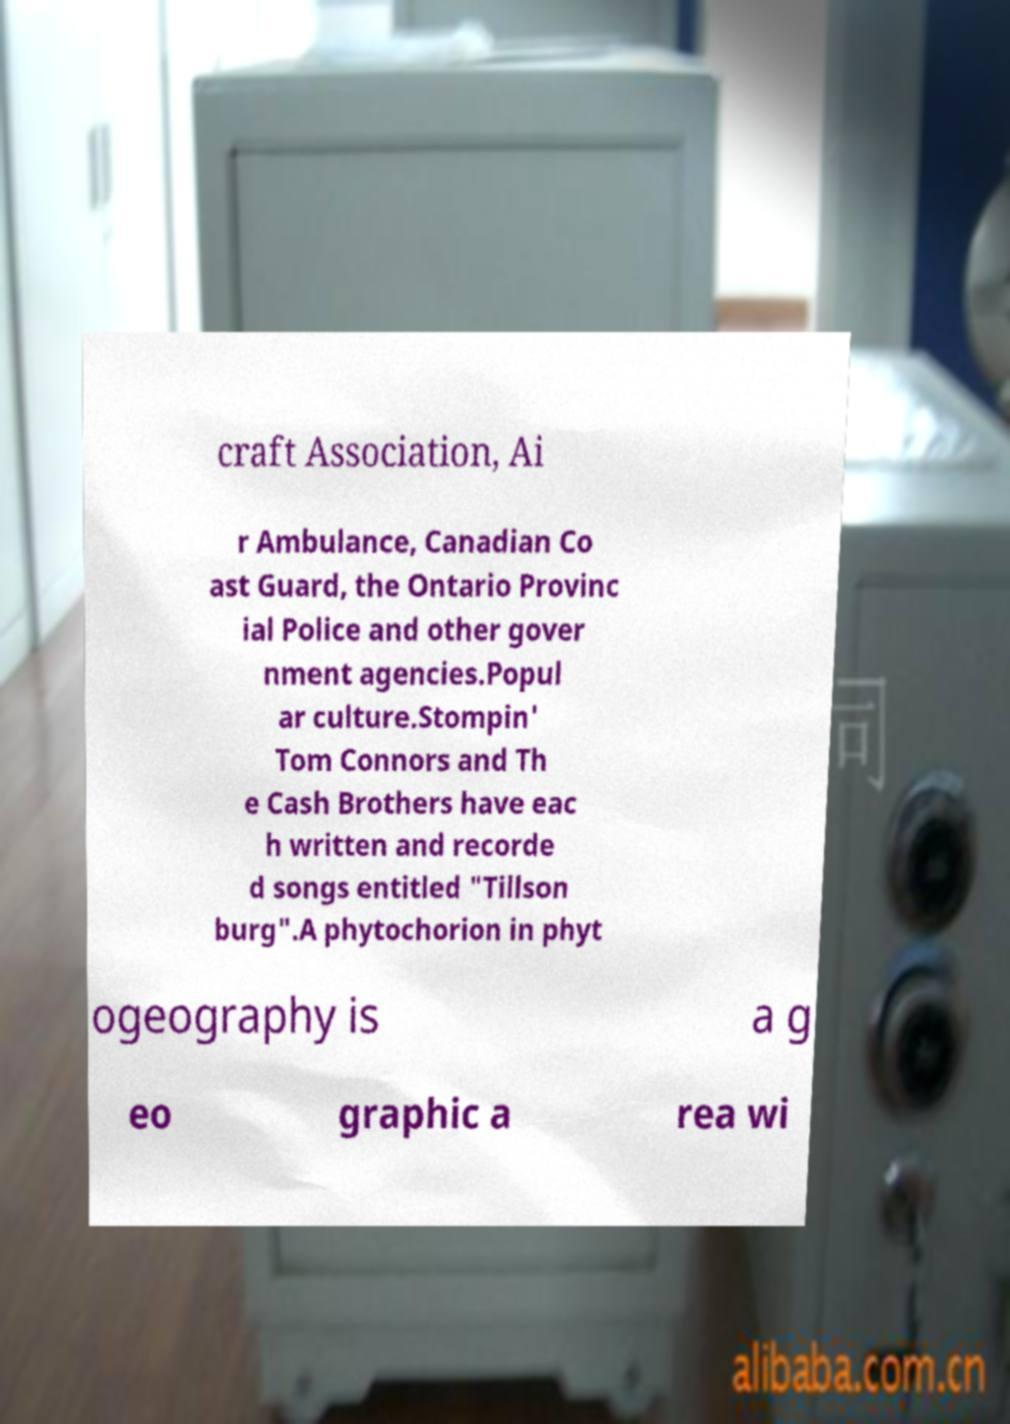Please identify and transcribe the text found in this image. craft Association, Ai r Ambulance, Canadian Co ast Guard, the Ontario Provinc ial Police and other gover nment agencies.Popul ar culture.Stompin' Tom Connors and Th e Cash Brothers have eac h written and recorde d songs entitled "Tillson burg".A phytochorion in phyt ogeography is a g eo graphic a rea wi 